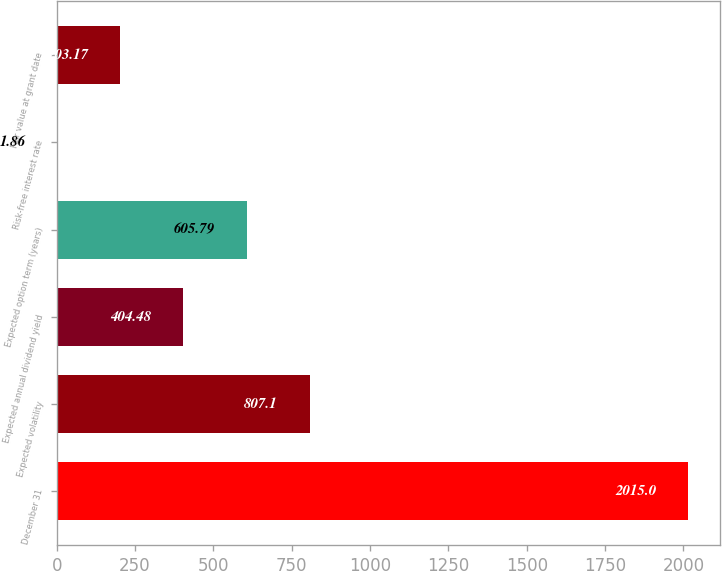Convert chart. <chart><loc_0><loc_0><loc_500><loc_500><bar_chart><fcel>December 31<fcel>Expected volatility<fcel>Expected annual dividend yield<fcel>Expected option term (years)<fcel>Risk-free interest rate<fcel>Fair value at grant date<nl><fcel>2015<fcel>807.1<fcel>404.48<fcel>605.79<fcel>1.86<fcel>203.17<nl></chart> 